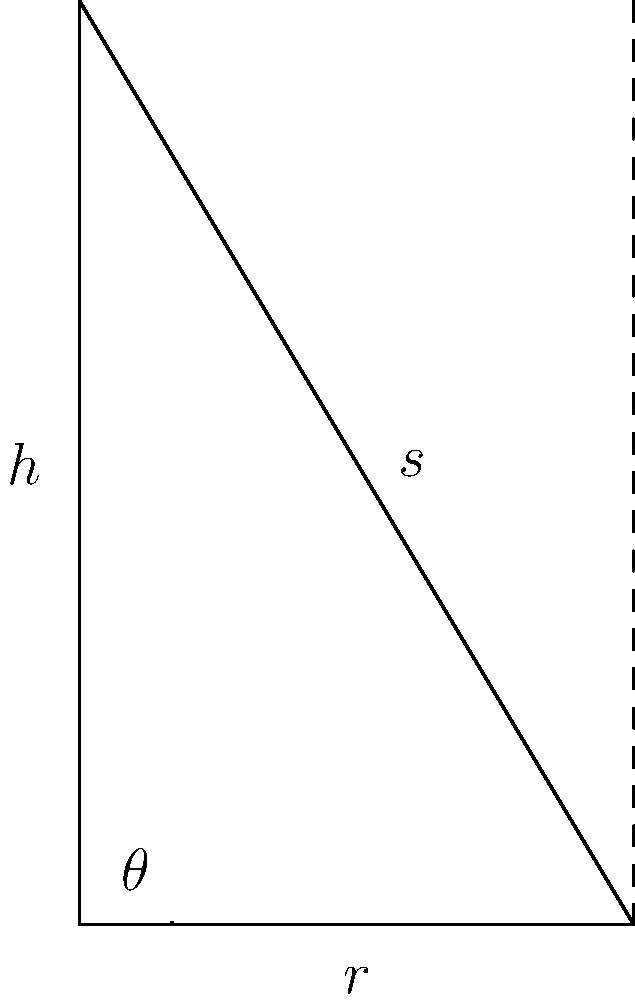During a deep-sea expedition, you discover a conical underwater volcano. Using sonar technology, you measure the height (h) of the volcano to be 500 meters and the radius (r) of its base to be 300 meters. What is the volume of this underwater volcano in cubic meters? Round your answer to the nearest whole number. To calculate the volume of a cone, we use the formula:

$$V = \frac{1}{3}\pi r^2h$$

Where:
$V$ = volume
$r$ = radius of the base
$h$ = height of the cone

Given:
$h = 500$ meters
$r = 300$ meters

Let's substitute these values into the formula:

$$V = \frac{1}{3}\pi (300)^2(500)$$

Now, let's calculate step by step:

1) First, calculate $r^2$:
   $300^2 = 90,000$

2) Multiply by $h$:
   $90,000 \times 500 = 45,000,000$

3) Multiply by $\frac{1}{3}\pi$:
   $\frac{1}{3}\pi \times 45,000,000 \approx 47,123,889.8$

4) Round to the nearest whole number:
   $47,123,890$ cubic meters

Therefore, the volume of the underwater volcano is approximately 47,123,890 cubic meters.
Answer: 47,123,890 cubic meters 